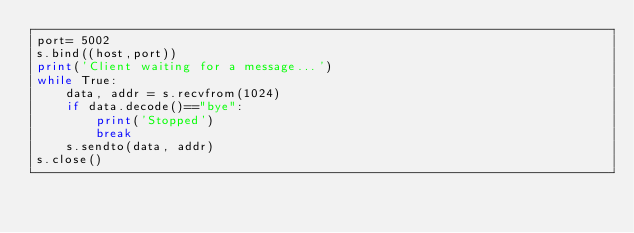<code> <loc_0><loc_0><loc_500><loc_500><_Python_>port= 5002
s.bind((host,port))
print('Client waiting for a message...')
while True:
    data, addr = s.recvfrom(1024)
    if data.decode()=="bye":
        print('Stopped')
        break
    s.sendto(data, addr)
s.close()

</code> 